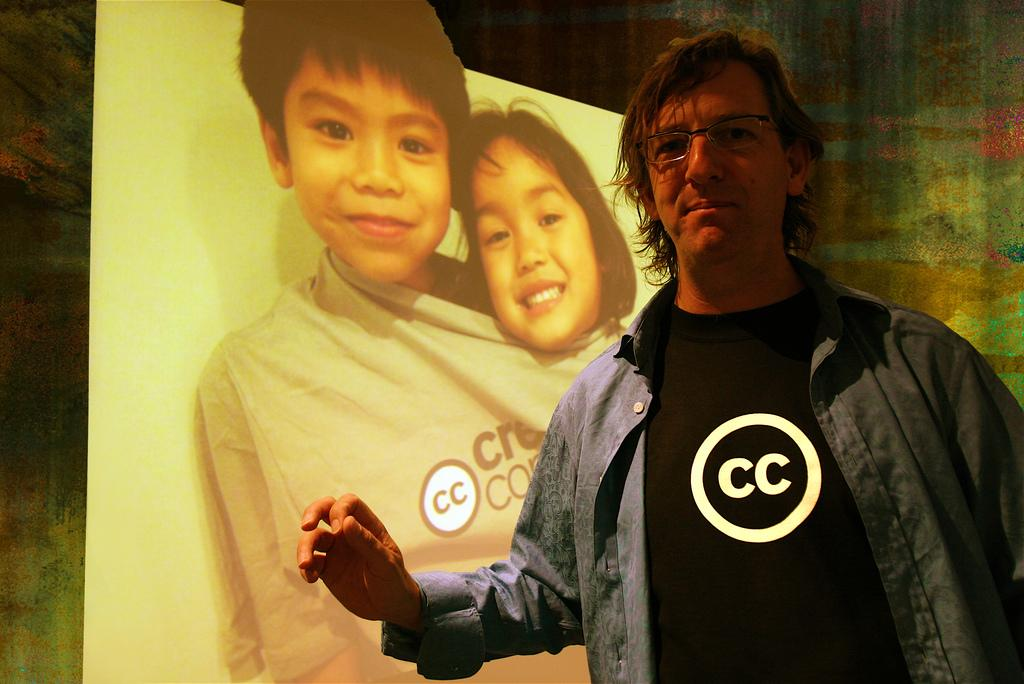What is the person in the image wearing? The person in the image is wearing a black t-shirt. Where is the person standing in relation to the hoarding? The person is standing near a hoarding. What is depicted on the hoarding? The hoarding features a boy and a girl wearing the same t-shirt. What are the expressions of the boy and girl on the hoarding? The boy and girl on the hoarding are smiling. What is the position of the boy and girl on the hoarding? The boy and girl on the hoarding are standing. What can be seen in the background of the image? There is a wall in the background of the image. What type of fang can be seen in the person's mouth in the image? There is no fang visible in the person's mouth in the image. What part of the person's body is covered by the t-shirt in the image? The person's t-shirt covers their upper body, including their torso and arms. 